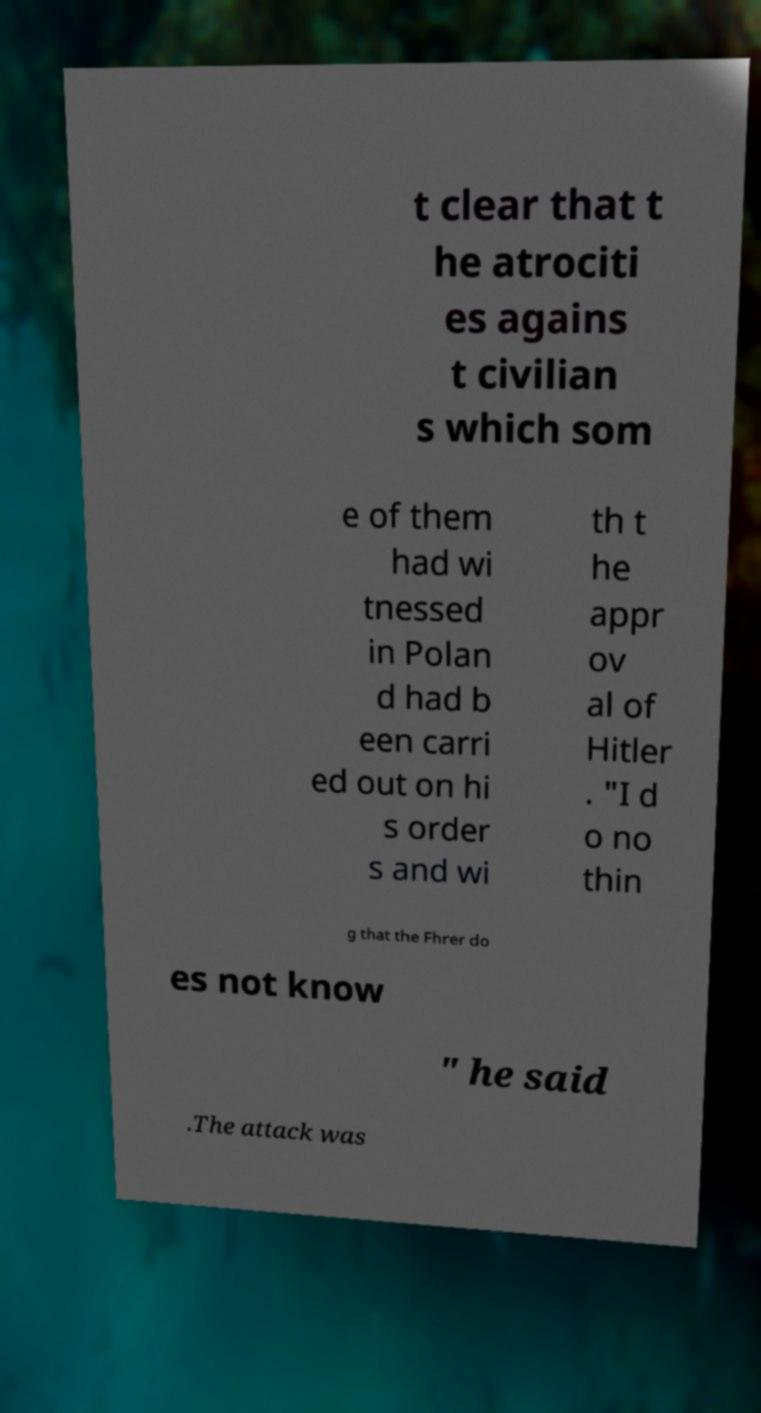Could you assist in decoding the text presented in this image and type it out clearly? t clear that t he atrociti es agains t civilian s which som e of them had wi tnessed in Polan d had b een carri ed out on hi s order s and wi th t he appr ov al of Hitler . "I d o no thin g that the Fhrer do es not know " he said .The attack was 